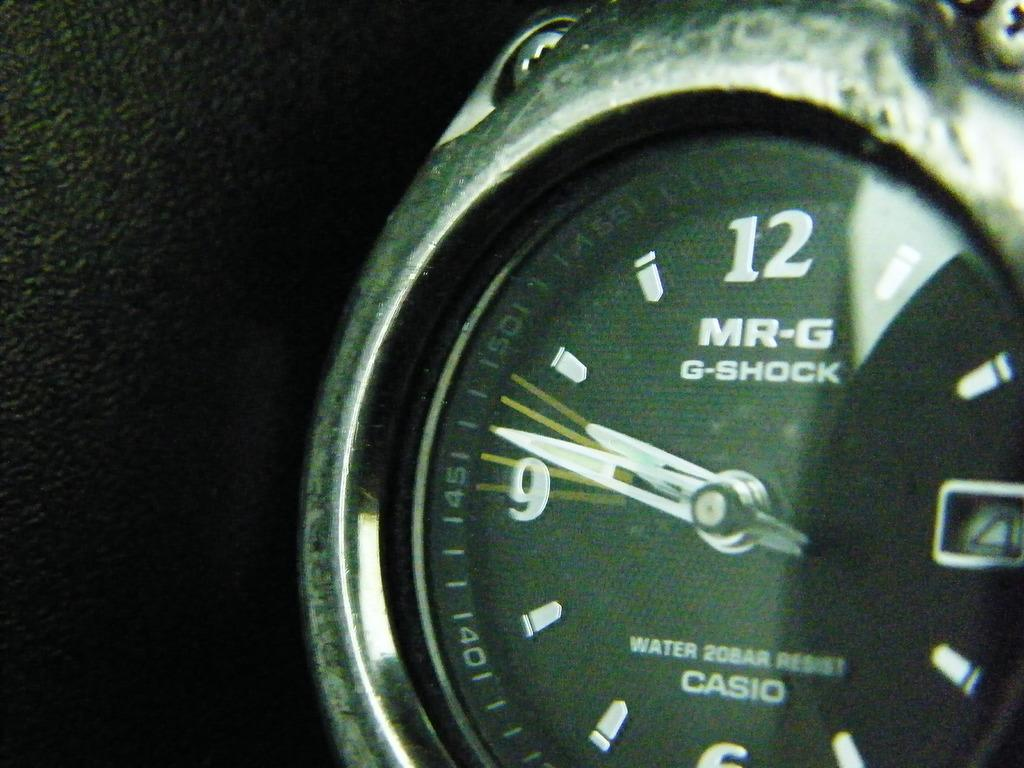What object is the main focus of the image? There is a watch in the image. What are the two main components of the watch? The watch has a short hand and a long hand. What is used to indicate the time on the watch? There are numbers on the frame of the watch. What material is located beside the watch? There is leather beside the watch. How many cars can be seen driving through the leather in the image? There are no cars present in the image; it features a watch and leather. What type of flesh is visible on the watch in the image? There is no flesh visible on the watch in the image; it is a leather watch strap. 